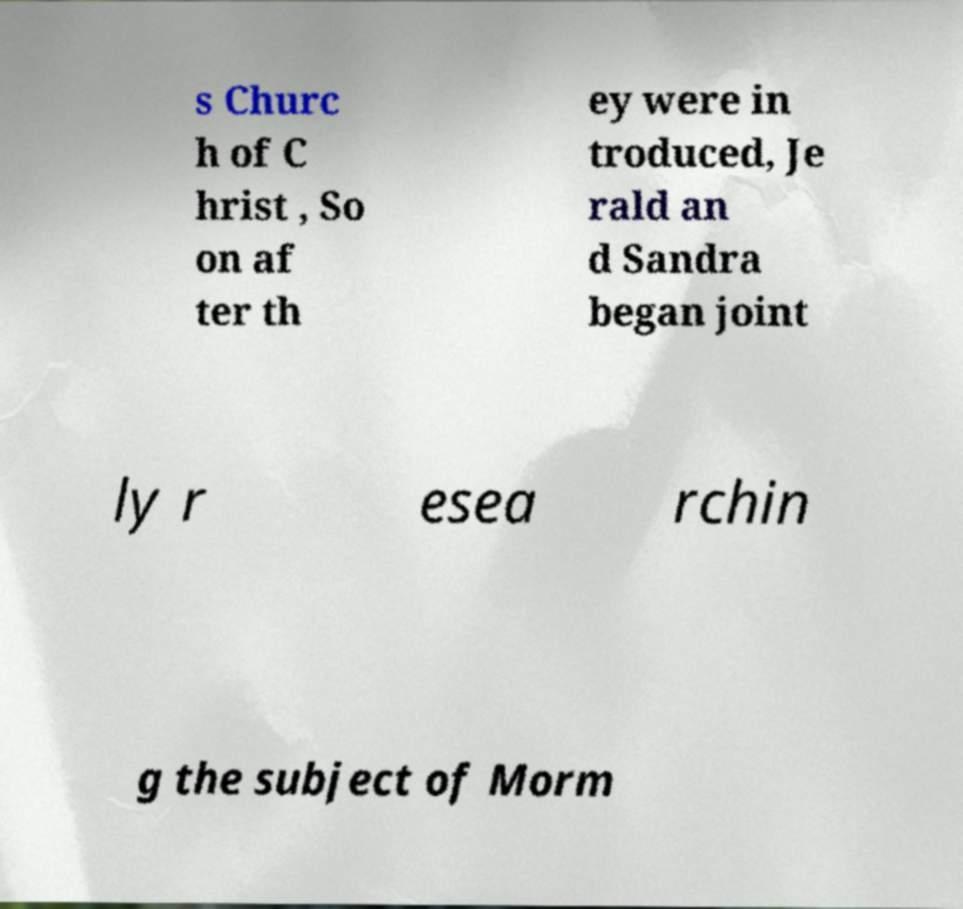There's text embedded in this image that I need extracted. Can you transcribe it verbatim? s Churc h of C hrist , So on af ter th ey were in troduced, Je rald an d Sandra began joint ly r esea rchin g the subject of Morm 